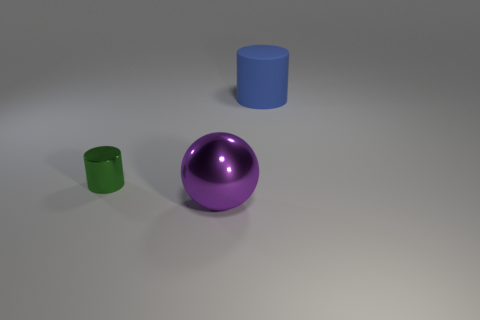Add 1 purple metallic things. How many objects exist? 4 Subtract all cylinders. How many objects are left? 1 Subtract all blue rubber cylinders. Subtract all green objects. How many objects are left? 1 Add 3 green objects. How many green objects are left? 4 Add 3 brown metallic cubes. How many brown metallic cubes exist? 3 Subtract 0 blue cubes. How many objects are left? 3 